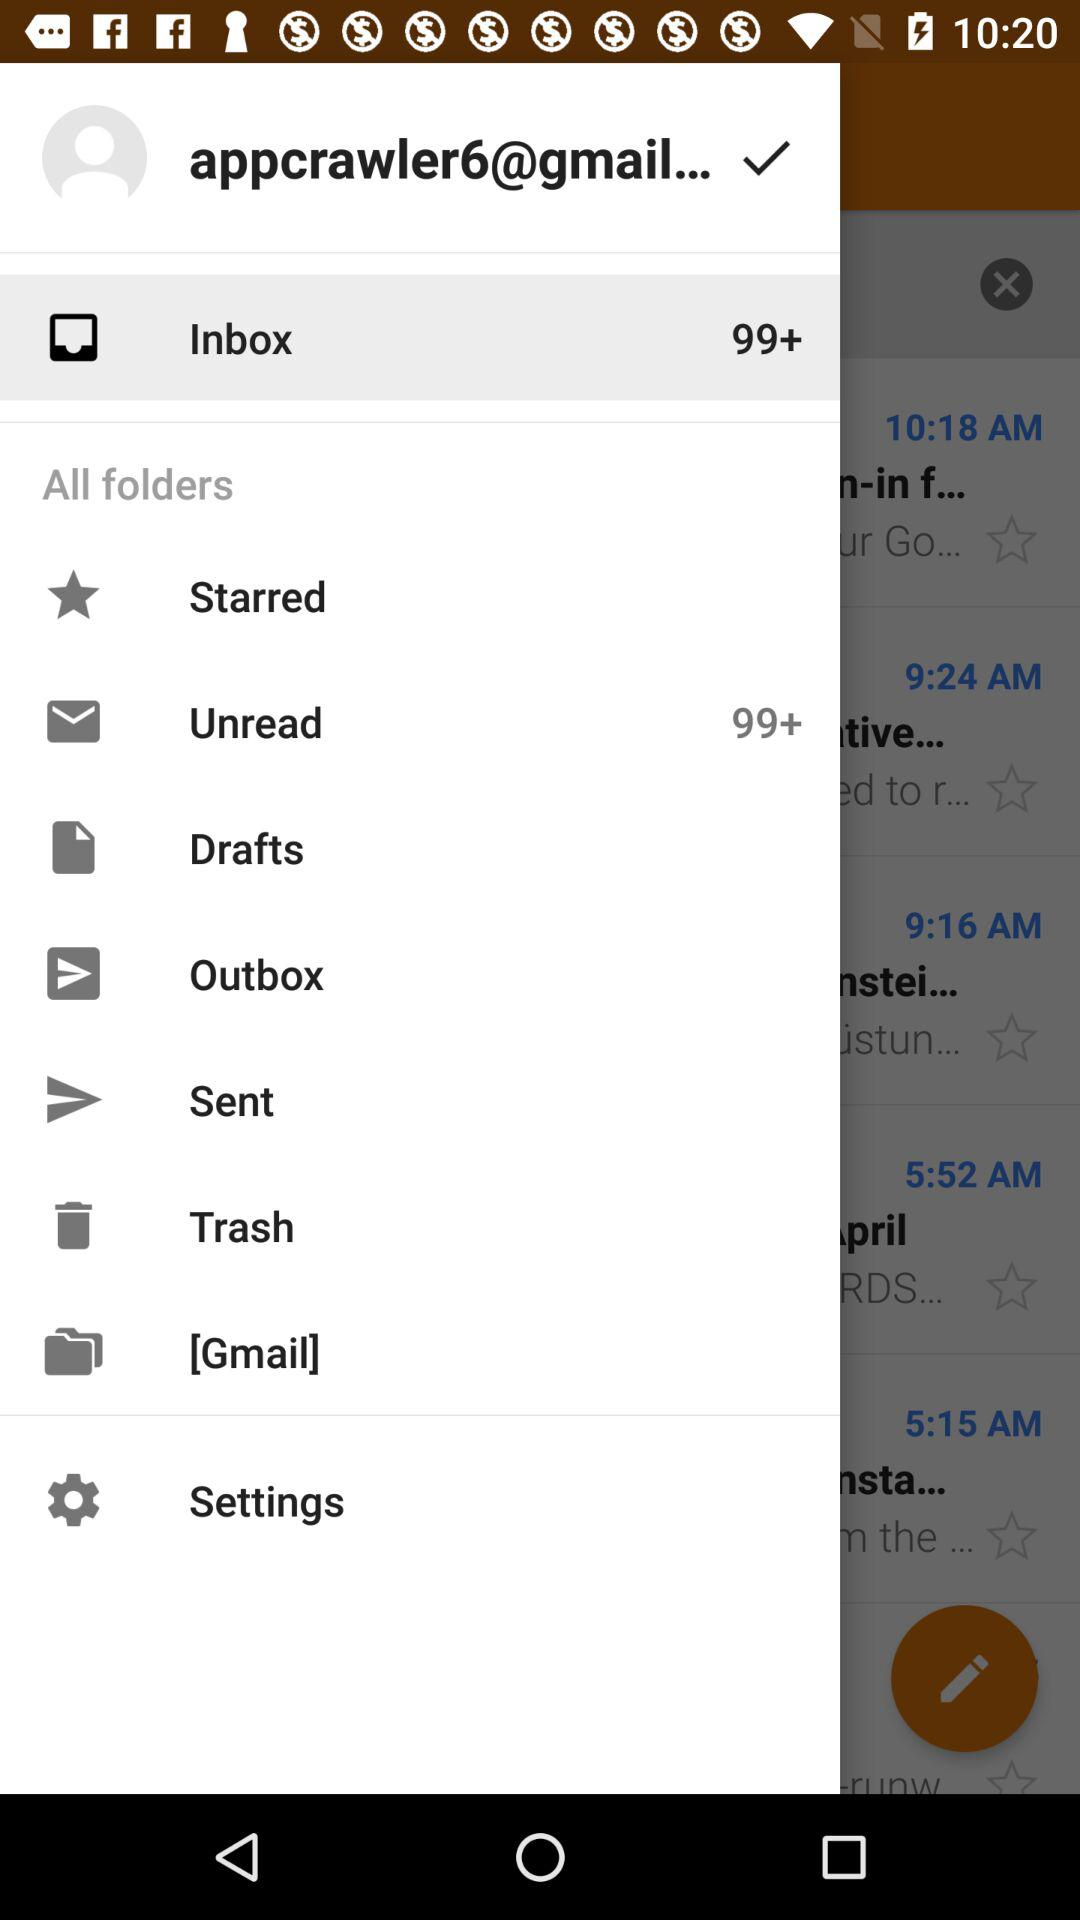How many unread emails are in the inbox? There are 99+ unread emails. 